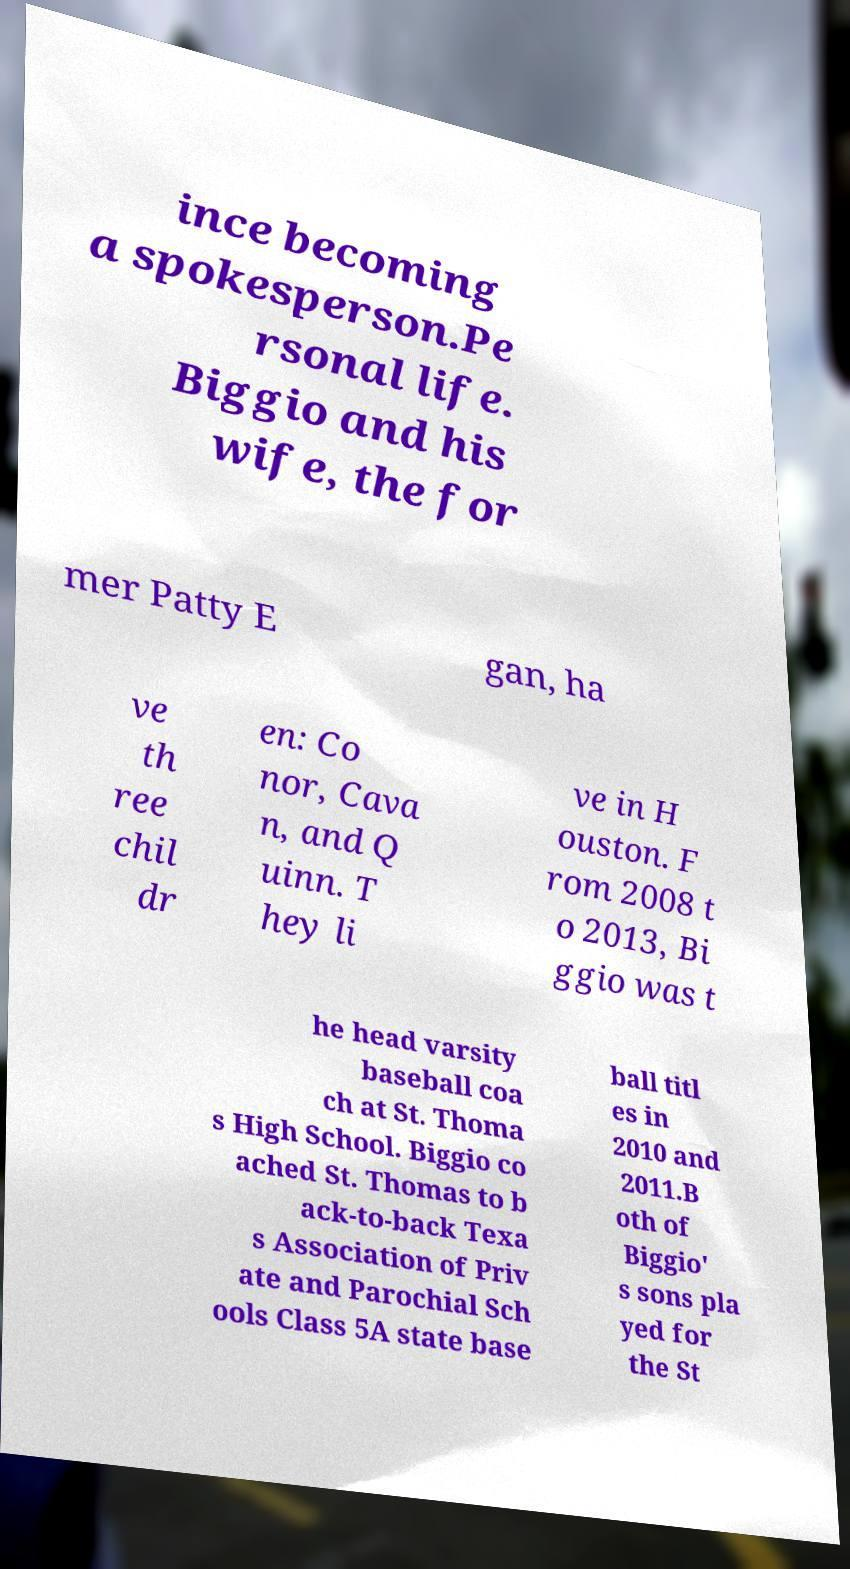Could you assist in decoding the text presented in this image and type it out clearly? ince becoming a spokesperson.Pe rsonal life. Biggio and his wife, the for mer Patty E gan, ha ve th ree chil dr en: Co nor, Cava n, and Q uinn. T hey li ve in H ouston. F rom 2008 t o 2013, Bi ggio was t he head varsity baseball coa ch at St. Thoma s High School. Biggio co ached St. Thomas to b ack-to-back Texa s Association of Priv ate and Parochial Sch ools Class 5A state base ball titl es in 2010 and 2011.B oth of Biggio' s sons pla yed for the St 